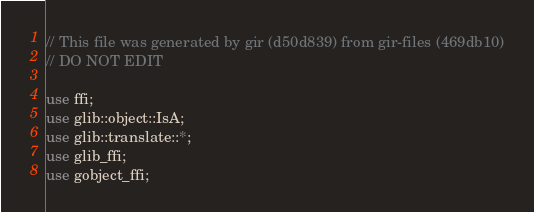Convert code to text. <code><loc_0><loc_0><loc_500><loc_500><_Rust_>// This file was generated by gir (d50d839) from gir-files (469db10)
// DO NOT EDIT

use ffi;
use glib::object::IsA;
use glib::translate::*;
use glib_ffi;
use gobject_ffi;</code> 